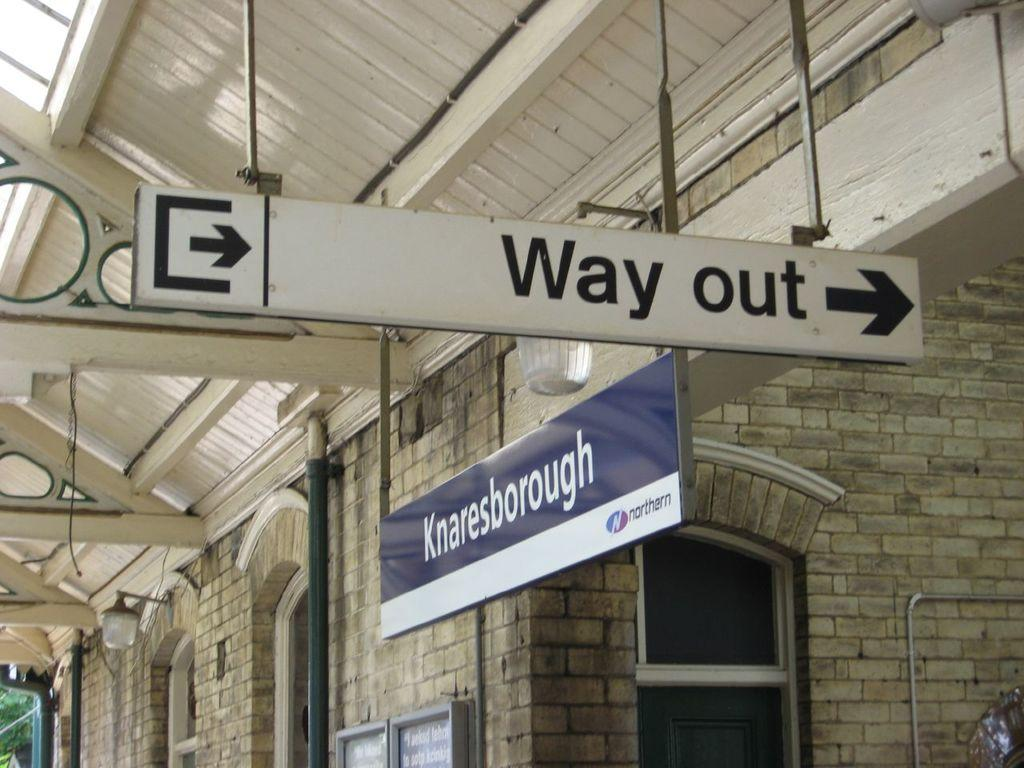What type of material can be seen in the image? There are boards and iron rods visible in the image. What architectural features are present in the image? There are windows and lights visible in the image. What might be the purpose of the iron rods in the image? The iron rods could be used for structural support or as part of a fence or railing. What type of building might be depicted in the image? The image appears to depict a building, possibly a commercial or industrial structure. What type of cream is being applied to the nail in the image? There is no cream or nail present in the image; it depicts a building with boards, windows, iron rods, and lights. 